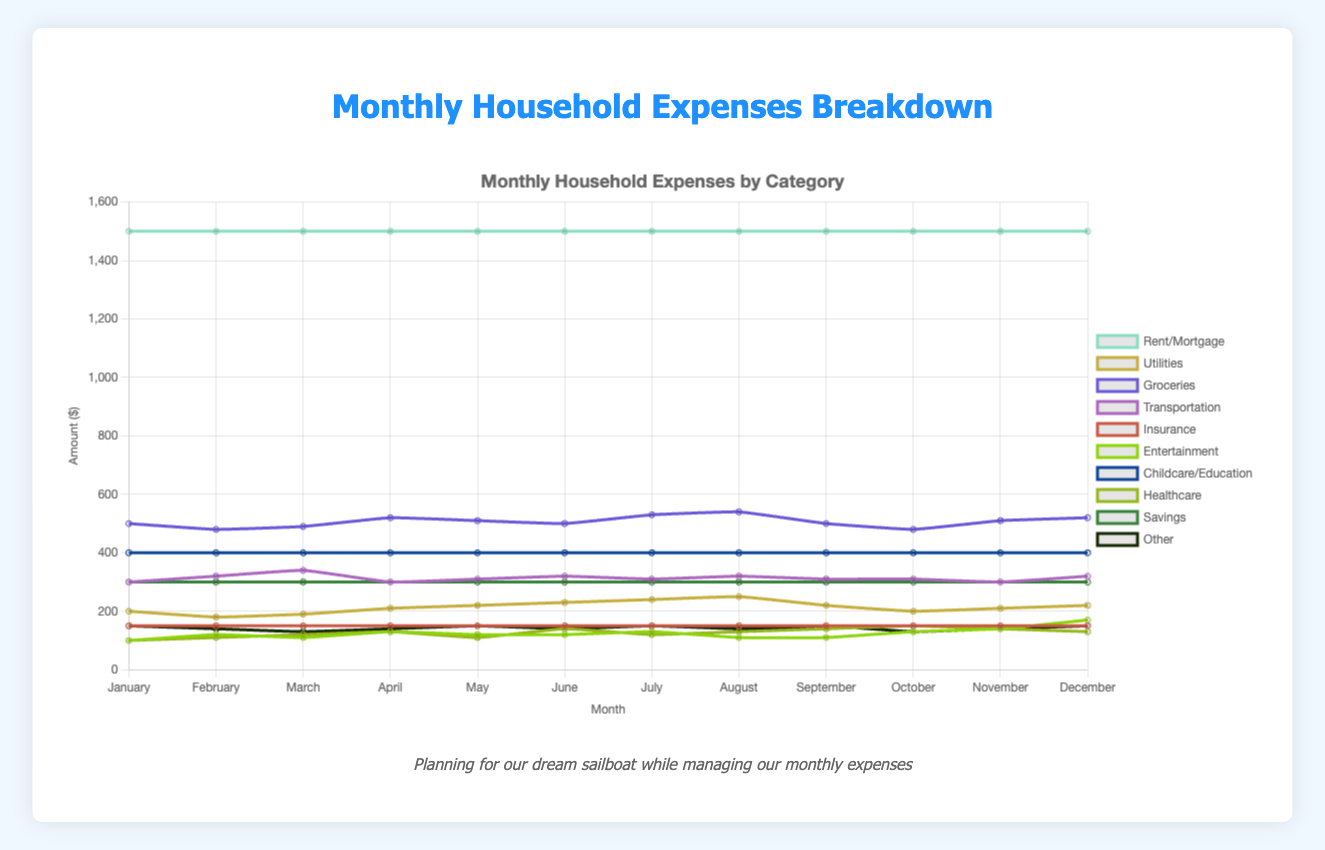Which category has the highest monthly expense throughout the year? By examining the line chart, the "Rent/Mortgage" category consistently shows the highest expenditure in each month, with a value of $1500.
Answer: Rent/Mortgage How did the monthly expenses for Groceries change from January to December? The expenditure on Groceries starts at $500 in January and fluctuates throughout the year, ending at $520 in December.
Answer: Increased by $20 What is the total amount spent on Utilities over the entire year? Sum the monthly Utilities expenses: 200 + 180 + 190 + 210 + 220 + 230 + 240 + 250 + 220 + 200 + 210 + 220 = 2570.
Answer: $2570 Which month had the highest total household expenses? Calculate the sum of all categories for each month and compare: December had the highest total, primarily due to higher Entertainment and Groceries expenses.
Answer: December In which month did the transportation expenses peak and what was the amount? Analyze the Transportation line in the chart, which reaches its highest point in March at $340.
Answer: March, $340 Compare the Entertainment expenses in July and December. Refer to the Entertainment line for July (130) and December (170) to see that December's value is higher.
Answer: December is higher What is the average monthly expense for Healthcare? Sum healthcare expenses and divide by 12: (100 + 110 + 120 + 130 + 110 + 140 + 120 + 130 + 140 + 150 + 140 + 130) / 12 = 130.
Answer: $130 Did the Childcare/Education expenses remain constant throughout the year? Inspect the Childcare/Education line, which remains at $400 every month, indicating no change.
Answer: Yes, constant at $400 Which month had the lowest total spent on Utilities, and what was the amount? Spot the minimum point on the Utilities line, which is $180 in February.
Answer: February, $180 What is the difference in Other expenses between March and December? Compare Other expenses for March ($130) and December ($150): difference is 150 - 130 = 20.
Answer: $20 